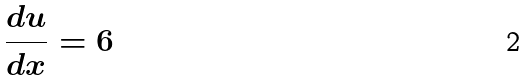Convert formula to latex. <formula><loc_0><loc_0><loc_500><loc_500>\frac { d u } { d x } = 6</formula> 